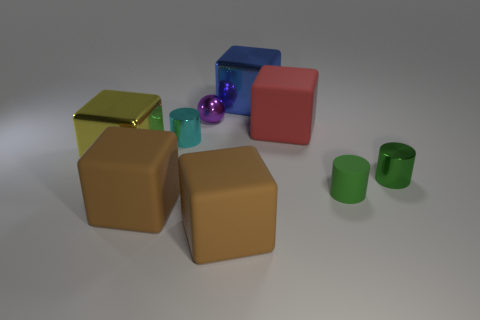What is the big thing behind the big matte block behind the shiny cube in front of the big blue thing made of?
Your answer should be compact. Metal. Does the yellow block have the same material as the purple thing?
Your answer should be compact. Yes. How many cylinders are either small green matte objects or tiny cyan objects?
Give a very brief answer. 2. There is a metal object that is left of the tiny cyan cylinder; what color is it?
Provide a succinct answer. Yellow. What number of metallic objects are either small green cylinders or cubes?
Ensure brevity in your answer.  3. What is the material of the cylinder that is left of the large metal cube that is behind the yellow metallic block?
Offer a very short reply. Metal. What is the material of the thing that is the same color as the tiny rubber cylinder?
Your answer should be very brief. Metal. What is the color of the tiny sphere?
Provide a short and direct response. Purple. There is a cylinder to the left of the blue cube; is there a large blue block that is to the left of it?
Keep it short and to the point. No. What material is the sphere?
Provide a short and direct response. Metal. 